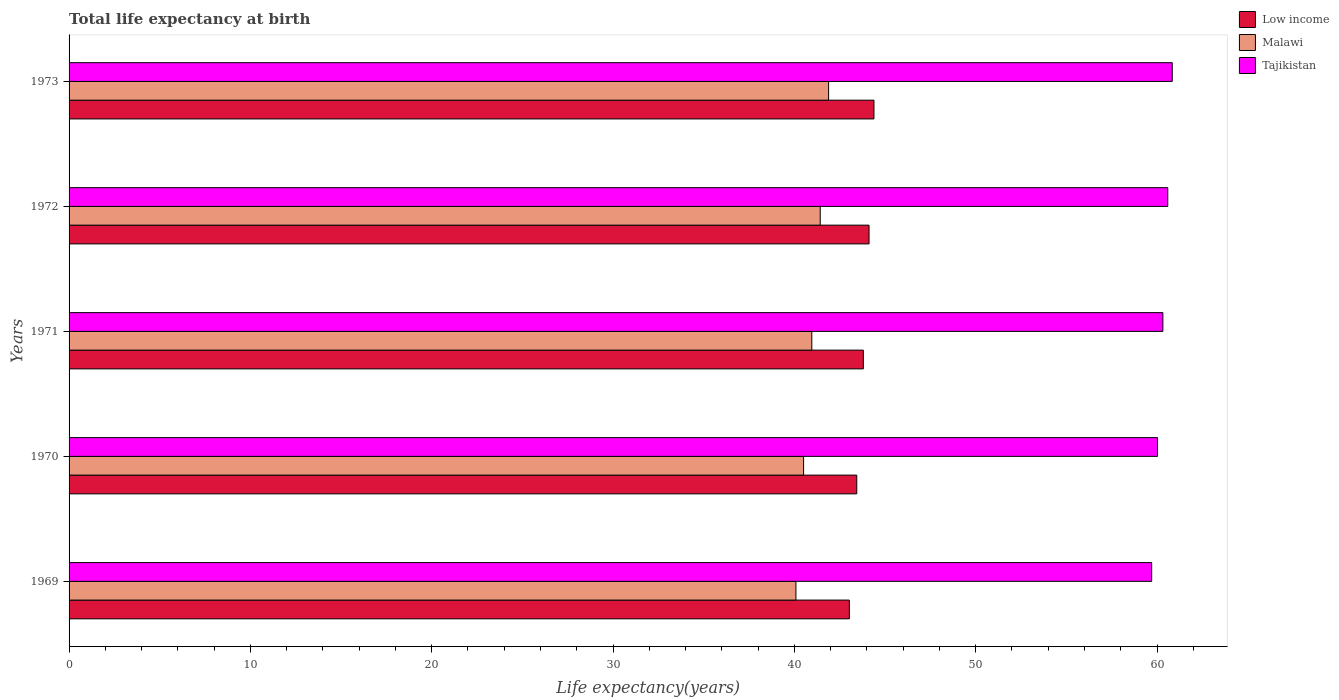How many groups of bars are there?
Keep it short and to the point. 5. Are the number of bars per tick equal to the number of legend labels?
Provide a succinct answer. Yes. Are the number of bars on each tick of the Y-axis equal?
Your answer should be very brief. Yes. How many bars are there on the 5th tick from the bottom?
Offer a very short reply. 3. What is the label of the 3rd group of bars from the top?
Offer a very short reply. 1971. What is the life expectancy at birth in in Malawi in 1970?
Make the answer very short. 40.51. Across all years, what is the maximum life expectancy at birth in in Low income?
Make the answer very short. 44.39. Across all years, what is the minimum life expectancy at birth in in Tajikistan?
Offer a terse response. 59.71. In which year was the life expectancy at birth in in Tajikistan maximum?
Ensure brevity in your answer.  1973. In which year was the life expectancy at birth in in Low income minimum?
Your response must be concise. 1969. What is the total life expectancy at birth in in Tajikistan in the graph?
Keep it short and to the point. 301.5. What is the difference between the life expectancy at birth in in Tajikistan in 1969 and that in 1972?
Offer a very short reply. -0.89. What is the difference between the life expectancy at birth in in Low income in 1969 and the life expectancy at birth in in Malawi in 1973?
Offer a terse response. 1.14. What is the average life expectancy at birth in in Tajikistan per year?
Make the answer very short. 60.3. In the year 1969, what is the difference between the life expectancy at birth in in Low income and life expectancy at birth in in Malawi?
Your answer should be compact. 2.95. What is the ratio of the life expectancy at birth in in Tajikistan in 1972 to that in 1973?
Make the answer very short. 1. What is the difference between the highest and the second highest life expectancy at birth in in Malawi?
Your answer should be compact. 0.46. What is the difference between the highest and the lowest life expectancy at birth in in Low income?
Provide a short and direct response. 1.36. Is it the case that in every year, the sum of the life expectancy at birth in in Low income and life expectancy at birth in in Tajikistan is greater than the life expectancy at birth in in Malawi?
Make the answer very short. Yes. How many bars are there?
Your answer should be very brief. 15. Are the values on the major ticks of X-axis written in scientific E-notation?
Your response must be concise. No. Does the graph contain grids?
Your answer should be very brief. No. How many legend labels are there?
Give a very brief answer. 3. What is the title of the graph?
Provide a short and direct response. Total life expectancy at birth. What is the label or title of the X-axis?
Provide a succinct answer. Life expectancy(years). What is the label or title of the Y-axis?
Your response must be concise. Years. What is the Life expectancy(years) in Low income in 1969?
Ensure brevity in your answer.  43.03. What is the Life expectancy(years) in Malawi in 1969?
Make the answer very short. 40.09. What is the Life expectancy(years) of Tajikistan in 1969?
Ensure brevity in your answer.  59.71. What is the Life expectancy(years) of Low income in 1970?
Make the answer very short. 43.44. What is the Life expectancy(years) in Malawi in 1970?
Keep it short and to the point. 40.51. What is the Life expectancy(years) in Tajikistan in 1970?
Provide a succinct answer. 60.03. What is the Life expectancy(years) in Low income in 1971?
Make the answer very short. 43.8. What is the Life expectancy(years) of Malawi in 1971?
Keep it short and to the point. 40.96. What is the Life expectancy(years) in Tajikistan in 1971?
Offer a very short reply. 60.32. What is the Life expectancy(years) in Low income in 1972?
Offer a very short reply. 44.12. What is the Life expectancy(years) of Malawi in 1972?
Your response must be concise. 41.43. What is the Life expectancy(years) in Tajikistan in 1972?
Make the answer very short. 60.59. What is the Life expectancy(years) of Low income in 1973?
Give a very brief answer. 44.39. What is the Life expectancy(years) in Malawi in 1973?
Ensure brevity in your answer.  41.89. What is the Life expectancy(years) in Tajikistan in 1973?
Offer a very short reply. 60.84. Across all years, what is the maximum Life expectancy(years) in Low income?
Provide a short and direct response. 44.39. Across all years, what is the maximum Life expectancy(years) in Malawi?
Your answer should be very brief. 41.89. Across all years, what is the maximum Life expectancy(years) in Tajikistan?
Keep it short and to the point. 60.84. Across all years, what is the minimum Life expectancy(years) of Low income?
Give a very brief answer. 43.03. Across all years, what is the minimum Life expectancy(years) in Malawi?
Make the answer very short. 40.09. Across all years, what is the minimum Life expectancy(years) of Tajikistan?
Your response must be concise. 59.71. What is the total Life expectancy(years) in Low income in the graph?
Keep it short and to the point. 218.79. What is the total Life expectancy(years) of Malawi in the graph?
Make the answer very short. 204.87. What is the total Life expectancy(years) in Tajikistan in the graph?
Offer a terse response. 301.5. What is the difference between the Life expectancy(years) in Low income in 1969 and that in 1970?
Provide a succinct answer. -0.41. What is the difference between the Life expectancy(years) of Malawi in 1969 and that in 1970?
Keep it short and to the point. -0.42. What is the difference between the Life expectancy(years) of Tajikistan in 1969 and that in 1970?
Provide a succinct answer. -0.32. What is the difference between the Life expectancy(years) of Low income in 1969 and that in 1971?
Your answer should be very brief. -0.77. What is the difference between the Life expectancy(years) in Malawi in 1969 and that in 1971?
Your answer should be compact. -0.88. What is the difference between the Life expectancy(years) of Tajikistan in 1969 and that in 1971?
Your answer should be very brief. -0.62. What is the difference between the Life expectancy(years) of Low income in 1969 and that in 1972?
Provide a succinct answer. -1.09. What is the difference between the Life expectancy(years) of Malawi in 1969 and that in 1972?
Your response must be concise. -1.34. What is the difference between the Life expectancy(years) in Tajikistan in 1969 and that in 1972?
Give a very brief answer. -0.89. What is the difference between the Life expectancy(years) in Low income in 1969 and that in 1973?
Ensure brevity in your answer.  -1.36. What is the difference between the Life expectancy(years) in Malawi in 1969 and that in 1973?
Offer a very short reply. -1.8. What is the difference between the Life expectancy(years) of Tajikistan in 1969 and that in 1973?
Ensure brevity in your answer.  -1.13. What is the difference between the Life expectancy(years) of Low income in 1970 and that in 1971?
Offer a very short reply. -0.36. What is the difference between the Life expectancy(years) of Malawi in 1970 and that in 1971?
Your answer should be compact. -0.45. What is the difference between the Life expectancy(years) of Tajikistan in 1970 and that in 1971?
Your answer should be compact. -0.29. What is the difference between the Life expectancy(years) of Low income in 1970 and that in 1972?
Make the answer very short. -0.68. What is the difference between the Life expectancy(years) of Malawi in 1970 and that in 1972?
Keep it short and to the point. -0.92. What is the difference between the Life expectancy(years) in Tajikistan in 1970 and that in 1972?
Offer a terse response. -0.56. What is the difference between the Life expectancy(years) in Low income in 1970 and that in 1973?
Your answer should be very brief. -0.95. What is the difference between the Life expectancy(years) in Malawi in 1970 and that in 1973?
Offer a very short reply. -1.38. What is the difference between the Life expectancy(years) in Tajikistan in 1970 and that in 1973?
Make the answer very short. -0.81. What is the difference between the Life expectancy(years) of Low income in 1971 and that in 1972?
Provide a succinct answer. -0.31. What is the difference between the Life expectancy(years) of Malawi in 1971 and that in 1972?
Your answer should be very brief. -0.47. What is the difference between the Life expectancy(years) in Tajikistan in 1971 and that in 1972?
Offer a very short reply. -0.27. What is the difference between the Life expectancy(years) in Low income in 1971 and that in 1973?
Your response must be concise. -0.59. What is the difference between the Life expectancy(years) in Malawi in 1971 and that in 1973?
Your answer should be very brief. -0.93. What is the difference between the Life expectancy(years) in Tajikistan in 1971 and that in 1973?
Your response must be concise. -0.52. What is the difference between the Life expectancy(years) in Low income in 1972 and that in 1973?
Provide a succinct answer. -0.27. What is the difference between the Life expectancy(years) in Malawi in 1972 and that in 1973?
Give a very brief answer. -0.46. What is the difference between the Life expectancy(years) of Tajikistan in 1972 and that in 1973?
Offer a very short reply. -0.25. What is the difference between the Life expectancy(years) in Low income in 1969 and the Life expectancy(years) in Malawi in 1970?
Make the answer very short. 2.52. What is the difference between the Life expectancy(years) of Low income in 1969 and the Life expectancy(years) of Tajikistan in 1970?
Keep it short and to the point. -17. What is the difference between the Life expectancy(years) in Malawi in 1969 and the Life expectancy(years) in Tajikistan in 1970?
Make the answer very short. -19.94. What is the difference between the Life expectancy(years) of Low income in 1969 and the Life expectancy(years) of Malawi in 1971?
Give a very brief answer. 2.07. What is the difference between the Life expectancy(years) in Low income in 1969 and the Life expectancy(years) in Tajikistan in 1971?
Make the answer very short. -17.29. What is the difference between the Life expectancy(years) of Malawi in 1969 and the Life expectancy(years) of Tajikistan in 1971?
Offer a terse response. -20.24. What is the difference between the Life expectancy(years) of Low income in 1969 and the Life expectancy(years) of Malawi in 1972?
Offer a very short reply. 1.61. What is the difference between the Life expectancy(years) of Low income in 1969 and the Life expectancy(years) of Tajikistan in 1972?
Your answer should be compact. -17.56. What is the difference between the Life expectancy(years) in Malawi in 1969 and the Life expectancy(years) in Tajikistan in 1972?
Your answer should be very brief. -20.51. What is the difference between the Life expectancy(years) of Low income in 1969 and the Life expectancy(years) of Malawi in 1973?
Provide a succinct answer. 1.14. What is the difference between the Life expectancy(years) of Low income in 1969 and the Life expectancy(years) of Tajikistan in 1973?
Make the answer very short. -17.81. What is the difference between the Life expectancy(years) in Malawi in 1969 and the Life expectancy(years) in Tajikistan in 1973?
Give a very brief answer. -20.76. What is the difference between the Life expectancy(years) in Low income in 1970 and the Life expectancy(years) in Malawi in 1971?
Make the answer very short. 2.48. What is the difference between the Life expectancy(years) in Low income in 1970 and the Life expectancy(years) in Tajikistan in 1971?
Your response must be concise. -16.88. What is the difference between the Life expectancy(years) in Malawi in 1970 and the Life expectancy(years) in Tajikistan in 1971?
Offer a very short reply. -19.81. What is the difference between the Life expectancy(years) of Low income in 1970 and the Life expectancy(years) of Malawi in 1972?
Keep it short and to the point. 2.01. What is the difference between the Life expectancy(years) in Low income in 1970 and the Life expectancy(years) in Tajikistan in 1972?
Keep it short and to the point. -17.15. What is the difference between the Life expectancy(years) in Malawi in 1970 and the Life expectancy(years) in Tajikistan in 1972?
Give a very brief answer. -20.09. What is the difference between the Life expectancy(years) in Low income in 1970 and the Life expectancy(years) in Malawi in 1973?
Your answer should be compact. 1.55. What is the difference between the Life expectancy(years) of Low income in 1970 and the Life expectancy(years) of Tajikistan in 1973?
Ensure brevity in your answer.  -17.4. What is the difference between the Life expectancy(years) of Malawi in 1970 and the Life expectancy(years) of Tajikistan in 1973?
Offer a very short reply. -20.33. What is the difference between the Life expectancy(years) in Low income in 1971 and the Life expectancy(years) in Malawi in 1972?
Make the answer very short. 2.38. What is the difference between the Life expectancy(years) of Low income in 1971 and the Life expectancy(years) of Tajikistan in 1972?
Provide a succinct answer. -16.79. What is the difference between the Life expectancy(years) of Malawi in 1971 and the Life expectancy(years) of Tajikistan in 1972?
Provide a succinct answer. -19.63. What is the difference between the Life expectancy(years) of Low income in 1971 and the Life expectancy(years) of Malawi in 1973?
Your answer should be compact. 1.92. What is the difference between the Life expectancy(years) of Low income in 1971 and the Life expectancy(years) of Tajikistan in 1973?
Give a very brief answer. -17.04. What is the difference between the Life expectancy(years) in Malawi in 1971 and the Life expectancy(years) in Tajikistan in 1973?
Give a very brief answer. -19.88. What is the difference between the Life expectancy(years) in Low income in 1972 and the Life expectancy(years) in Malawi in 1973?
Offer a very short reply. 2.23. What is the difference between the Life expectancy(years) of Low income in 1972 and the Life expectancy(years) of Tajikistan in 1973?
Give a very brief answer. -16.72. What is the difference between the Life expectancy(years) of Malawi in 1972 and the Life expectancy(years) of Tajikistan in 1973?
Your answer should be very brief. -19.41. What is the average Life expectancy(years) in Low income per year?
Make the answer very short. 43.76. What is the average Life expectancy(years) in Malawi per year?
Keep it short and to the point. 40.98. What is the average Life expectancy(years) of Tajikistan per year?
Give a very brief answer. 60.3. In the year 1969, what is the difference between the Life expectancy(years) in Low income and Life expectancy(years) in Malawi?
Offer a very short reply. 2.95. In the year 1969, what is the difference between the Life expectancy(years) in Low income and Life expectancy(years) in Tajikistan?
Provide a short and direct response. -16.67. In the year 1969, what is the difference between the Life expectancy(years) of Malawi and Life expectancy(years) of Tajikistan?
Your response must be concise. -19.62. In the year 1970, what is the difference between the Life expectancy(years) in Low income and Life expectancy(years) in Malawi?
Your response must be concise. 2.93. In the year 1970, what is the difference between the Life expectancy(years) in Low income and Life expectancy(years) in Tajikistan?
Your answer should be very brief. -16.59. In the year 1970, what is the difference between the Life expectancy(years) of Malawi and Life expectancy(years) of Tajikistan?
Keep it short and to the point. -19.52. In the year 1971, what is the difference between the Life expectancy(years) of Low income and Life expectancy(years) of Malawi?
Provide a succinct answer. 2.84. In the year 1971, what is the difference between the Life expectancy(years) of Low income and Life expectancy(years) of Tajikistan?
Provide a short and direct response. -16.52. In the year 1971, what is the difference between the Life expectancy(years) in Malawi and Life expectancy(years) in Tajikistan?
Provide a short and direct response. -19.36. In the year 1972, what is the difference between the Life expectancy(years) of Low income and Life expectancy(years) of Malawi?
Provide a succinct answer. 2.69. In the year 1972, what is the difference between the Life expectancy(years) of Low income and Life expectancy(years) of Tajikistan?
Provide a succinct answer. -16.48. In the year 1972, what is the difference between the Life expectancy(years) of Malawi and Life expectancy(years) of Tajikistan?
Offer a terse response. -19.17. In the year 1973, what is the difference between the Life expectancy(years) of Low income and Life expectancy(years) of Malawi?
Keep it short and to the point. 2.5. In the year 1973, what is the difference between the Life expectancy(years) of Low income and Life expectancy(years) of Tajikistan?
Provide a short and direct response. -16.45. In the year 1973, what is the difference between the Life expectancy(years) in Malawi and Life expectancy(years) in Tajikistan?
Make the answer very short. -18.95. What is the ratio of the Life expectancy(years) in Low income in 1969 to that in 1970?
Make the answer very short. 0.99. What is the ratio of the Life expectancy(years) in Malawi in 1969 to that in 1970?
Provide a short and direct response. 0.99. What is the ratio of the Life expectancy(years) in Low income in 1969 to that in 1971?
Make the answer very short. 0.98. What is the ratio of the Life expectancy(years) of Malawi in 1969 to that in 1971?
Your answer should be very brief. 0.98. What is the ratio of the Life expectancy(years) of Low income in 1969 to that in 1972?
Give a very brief answer. 0.98. What is the ratio of the Life expectancy(years) of Malawi in 1969 to that in 1972?
Your response must be concise. 0.97. What is the ratio of the Life expectancy(years) in Tajikistan in 1969 to that in 1972?
Ensure brevity in your answer.  0.99. What is the ratio of the Life expectancy(years) of Low income in 1969 to that in 1973?
Make the answer very short. 0.97. What is the ratio of the Life expectancy(years) of Tajikistan in 1969 to that in 1973?
Provide a succinct answer. 0.98. What is the ratio of the Life expectancy(years) in Low income in 1970 to that in 1971?
Your answer should be very brief. 0.99. What is the ratio of the Life expectancy(years) in Malawi in 1970 to that in 1971?
Provide a succinct answer. 0.99. What is the ratio of the Life expectancy(years) in Low income in 1970 to that in 1972?
Offer a very short reply. 0.98. What is the ratio of the Life expectancy(years) in Malawi in 1970 to that in 1972?
Your answer should be compact. 0.98. What is the ratio of the Life expectancy(years) of Tajikistan in 1970 to that in 1972?
Make the answer very short. 0.99. What is the ratio of the Life expectancy(years) of Low income in 1970 to that in 1973?
Make the answer very short. 0.98. What is the ratio of the Life expectancy(years) of Malawi in 1970 to that in 1973?
Offer a very short reply. 0.97. What is the ratio of the Life expectancy(years) in Tajikistan in 1970 to that in 1973?
Ensure brevity in your answer.  0.99. What is the ratio of the Life expectancy(years) of Low income in 1971 to that in 1972?
Provide a succinct answer. 0.99. What is the ratio of the Life expectancy(years) of Tajikistan in 1971 to that in 1972?
Make the answer very short. 1. What is the ratio of the Life expectancy(years) in Malawi in 1971 to that in 1973?
Make the answer very short. 0.98. What is the ratio of the Life expectancy(years) in Tajikistan in 1971 to that in 1973?
Your answer should be very brief. 0.99. What is the ratio of the Life expectancy(years) in Low income in 1972 to that in 1973?
Your response must be concise. 0.99. What is the ratio of the Life expectancy(years) of Tajikistan in 1972 to that in 1973?
Provide a short and direct response. 1. What is the difference between the highest and the second highest Life expectancy(years) in Low income?
Provide a succinct answer. 0.27. What is the difference between the highest and the second highest Life expectancy(years) of Malawi?
Keep it short and to the point. 0.46. What is the difference between the highest and the second highest Life expectancy(years) of Tajikistan?
Offer a terse response. 0.25. What is the difference between the highest and the lowest Life expectancy(years) of Low income?
Offer a very short reply. 1.36. What is the difference between the highest and the lowest Life expectancy(years) of Malawi?
Give a very brief answer. 1.8. What is the difference between the highest and the lowest Life expectancy(years) of Tajikistan?
Ensure brevity in your answer.  1.13. 